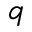Convert formula to latex. <formula><loc_0><loc_0><loc_500><loc_500>q</formula> 